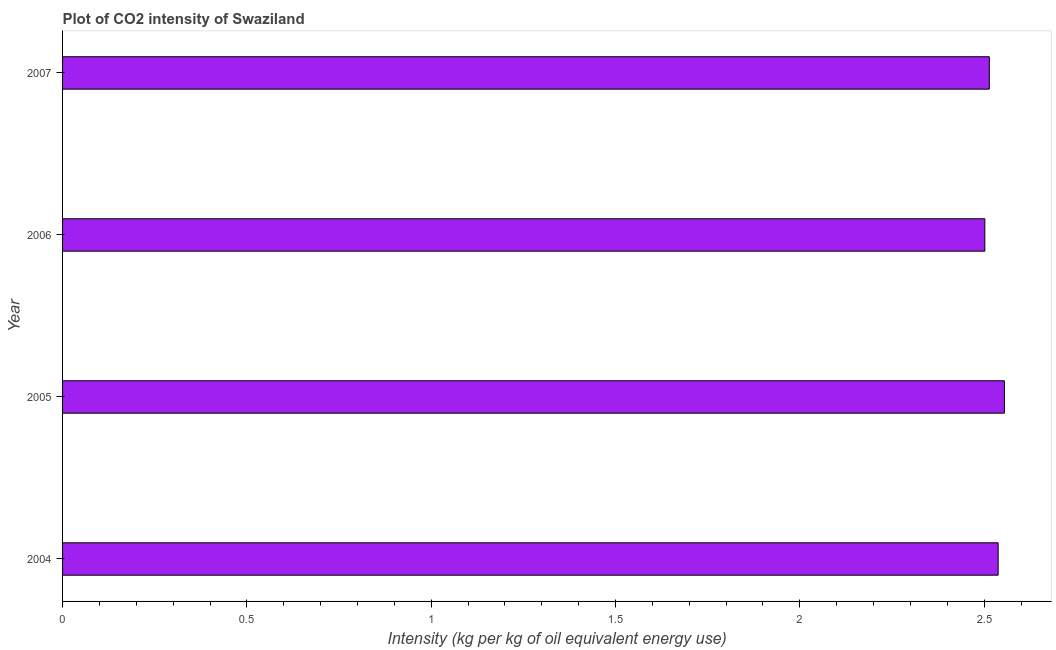Does the graph contain grids?
Ensure brevity in your answer.  No. What is the title of the graph?
Your answer should be compact. Plot of CO2 intensity of Swaziland. What is the label or title of the X-axis?
Your answer should be compact. Intensity (kg per kg of oil equivalent energy use). What is the label or title of the Y-axis?
Ensure brevity in your answer.  Year. What is the co2 intensity in 2004?
Provide a succinct answer. 2.54. Across all years, what is the maximum co2 intensity?
Offer a very short reply. 2.55. Across all years, what is the minimum co2 intensity?
Ensure brevity in your answer.  2.5. What is the sum of the co2 intensity?
Your response must be concise. 10.11. What is the difference between the co2 intensity in 2004 and 2006?
Ensure brevity in your answer.  0.04. What is the average co2 intensity per year?
Your response must be concise. 2.53. What is the median co2 intensity?
Ensure brevity in your answer.  2.53. In how many years, is the co2 intensity greater than 0.6 kg?
Keep it short and to the point. 4. Do a majority of the years between 2007 and 2005 (inclusive) have co2 intensity greater than 0.9 kg?
Your answer should be compact. Yes. What is the difference between the highest and the second highest co2 intensity?
Keep it short and to the point. 0.02. Is the sum of the co2 intensity in 2005 and 2007 greater than the maximum co2 intensity across all years?
Your response must be concise. Yes. What is the difference between two consecutive major ticks on the X-axis?
Give a very brief answer. 0.5. What is the Intensity (kg per kg of oil equivalent energy use) in 2004?
Keep it short and to the point. 2.54. What is the Intensity (kg per kg of oil equivalent energy use) in 2005?
Your answer should be compact. 2.55. What is the Intensity (kg per kg of oil equivalent energy use) of 2006?
Keep it short and to the point. 2.5. What is the Intensity (kg per kg of oil equivalent energy use) of 2007?
Your answer should be very brief. 2.51. What is the difference between the Intensity (kg per kg of oil equivalent energy use) in 2004 and 2005?
Your answer should be compact. -0.02. What is the difference between the Intensity (kg per kg of oil equivalent energy use) in 2004 and 2006?
Give a very brief answer. 0.04. What is the difference between the Intensity (kg per kg of oil equivalent energy use) in 2004 and 2007?
Provide a succinct answer. 0.02. What is the difference between the Intensity (kg per kg of oil equivalent energy use) in 2005 and 2006?
Your response must be concise. 0.05. What is the difference between the Intensity (kg per kg of oil equivalent energy use) in 2005 and 2007?
Keep it short and to the point. 0.04. What is the difference between the Intensity (kg per kg of oil equivalent energy use) in 2006 and 2007?
Your response must be concise. -0.01. What is the ratio of the Intensity (kg per kg of oil equivalent energy use) in 2004 to that in 2006?
Offer a terse response. 1.01. 